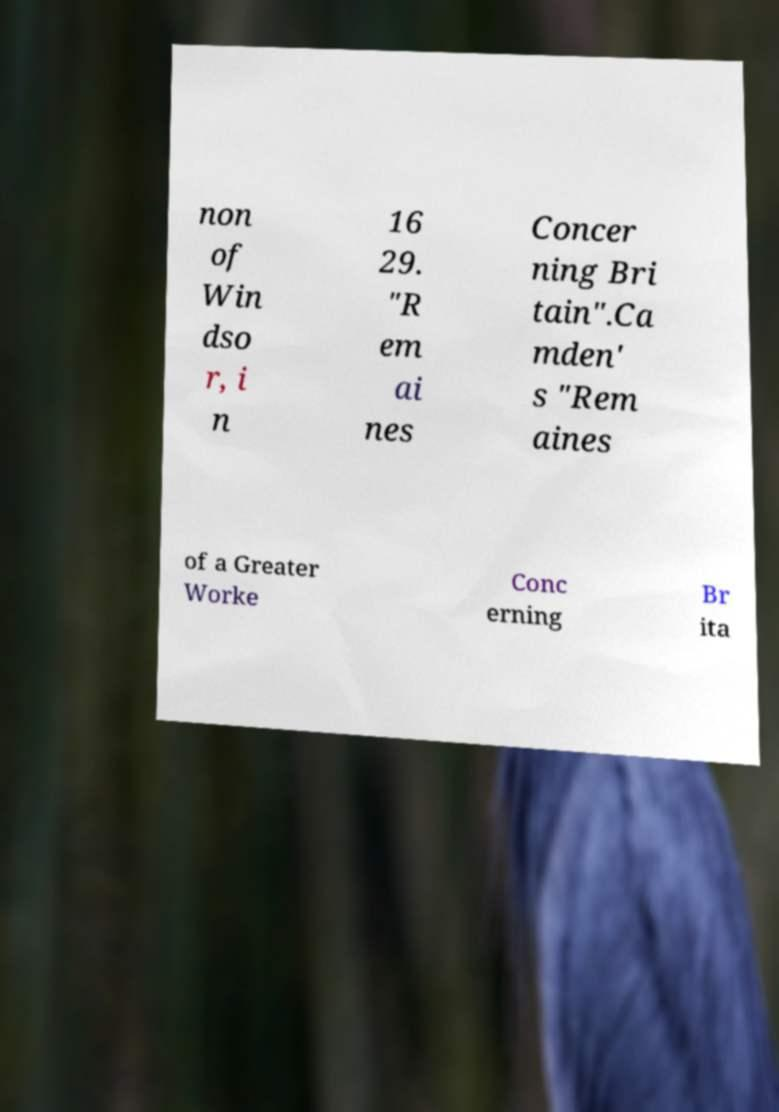What messages or text are displayed in this image? I need them in a readable, typed format. non of Win dso r, i n 16 29. "R em ai nes Concer ning Bri tain".Ca mden' s "Rem aines of a Greater Worke Conc erning Br ita 